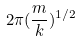Convert formula to latex. <formula><loc_0><loc_0><loc_500><loc_500>2 \pi ( \frac { m } { k } ) ^ { 1 / 2 }</formula> 